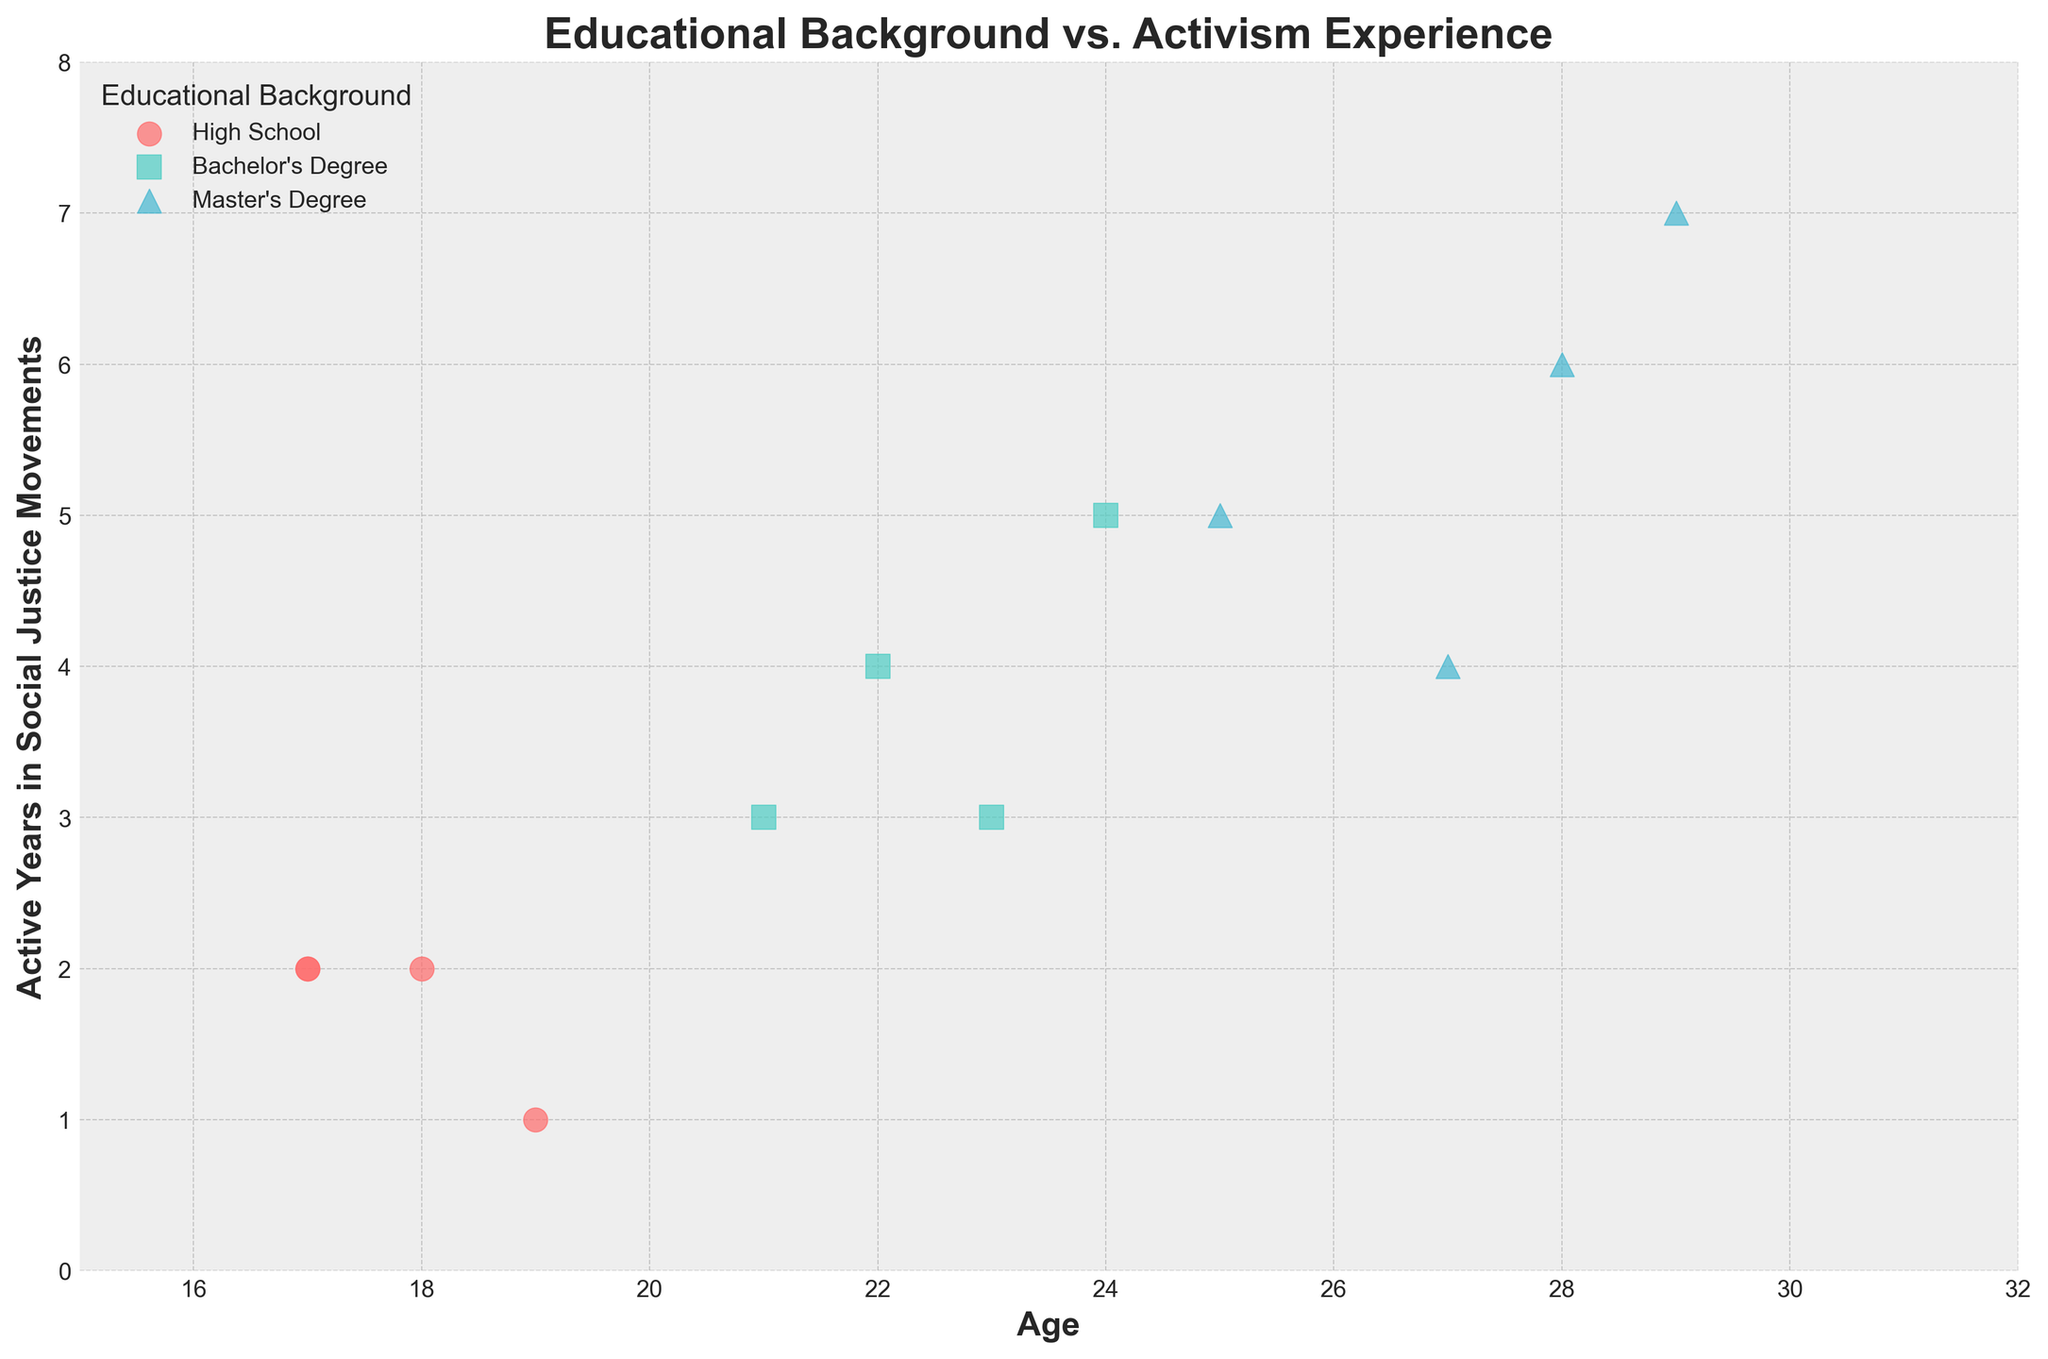What's the title of the figure? The title of the figure is usually located at the top of the plot. In this case, it's clearly displayed.
Answer: Educational Background vs. Activism Experience How many educational categories are represented in the figure? The legend in the figure shows the categories represented by different colors and markers.
Answer: Three Which educational background category has the largest spread in Active Years? In the figure, check the range (minimum to maximum) of 'Active Years' values for each educational background category.
Answer: Master's Degree How does age correspond to activism experience for those with a High School education? Observe the scatter points marked for the 'High School' category and note their positions on the Age and Active Years axes.
Answer: They are mostly young with low Active Years Which age group is associated with the most Active Years for a Master's Degree? Examine the scatter points for ‘Master’s Degree’ and identify the age corresponding to the highest 'Active Years'.
Answer: Around age 29 How many data points are there for Bachelor's Degree holders? Count the number of scatter points in the figure that correspond to the 'Bachelor's Degree' category.
Answer: Four Do Bachelor’s Degree holders have any points below age 20? Look at the Age axis for points associated with the 'Bachelor’s Degree' category. See if any fall below 20.
Answer: No Which group has individuals participating in Climate Change Protests? Identify the scatter points marked for Climate Change Protest and check their corresponding educational categories.
Answer: All groups (High School, Bachelor's Degree, Master's Degree) What is the average number of Active Years for Master’s Degree holders? Sum the active years for all Master's Degree scatter points and divide by their count (5+6+4+7 = 22; 22/4 = 5.5).
Answer: 5.5 Which group shows the most diversity in activism age? Compare the age ranges for scatter points across educational categories and identify which has the widest range.
Answer: Master's Degree 